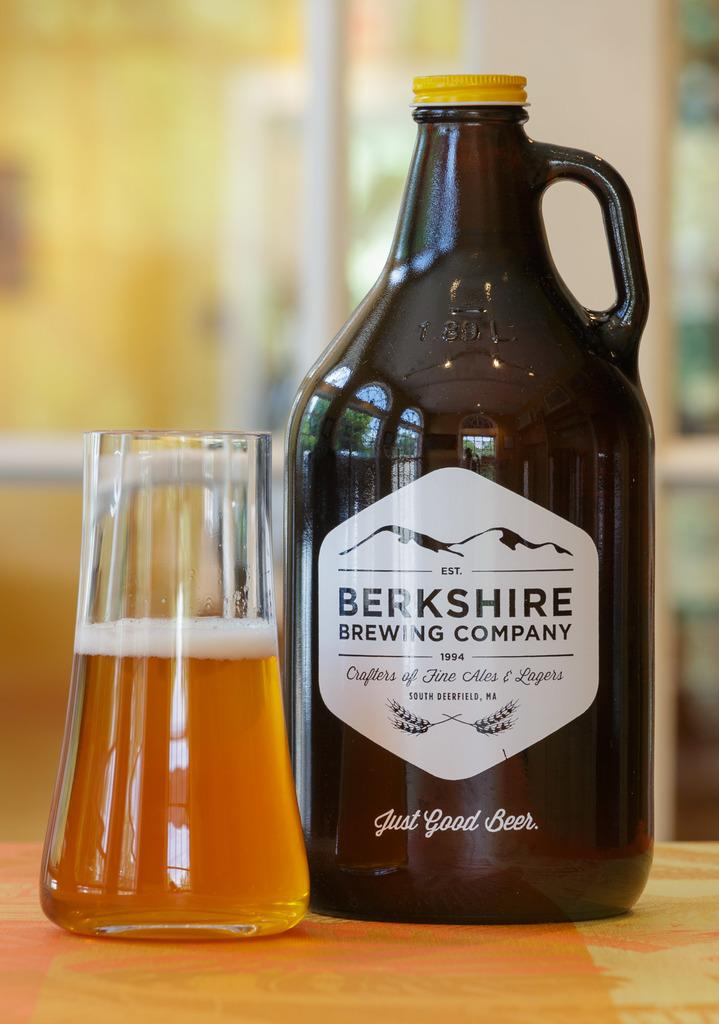What object can be seen in the image that might contain a liquid? There is a bottle in the image that might contain a liquid. What else in the image appears to contain a liquid? There is a glass with a drink in the image. Can you describe the background of the image? The background of the image is blurry. What type of powder is being used to create a shocking experience in the image? There is no powder or shocking experience present in the image. 